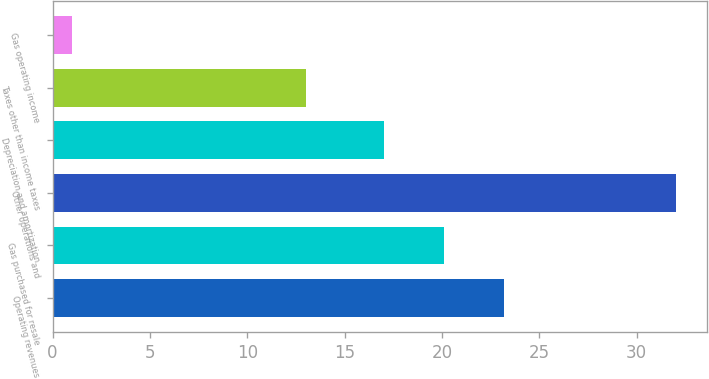Convert chart. <chart><loc_0><loc_0><loc_500><loc_500><bar_chart><fcel>Operating revenues<fcel>Gas purchased for resale<fcel>Other operations and<fcel>Depreciation and amortization<fcel>Taxes other than income taxes<fcel>Gas operating income<nl><fcel>23.2<fcel>20.1<fcel>32<fcel>17<fcel>13<fcel>1<nl></chart> 